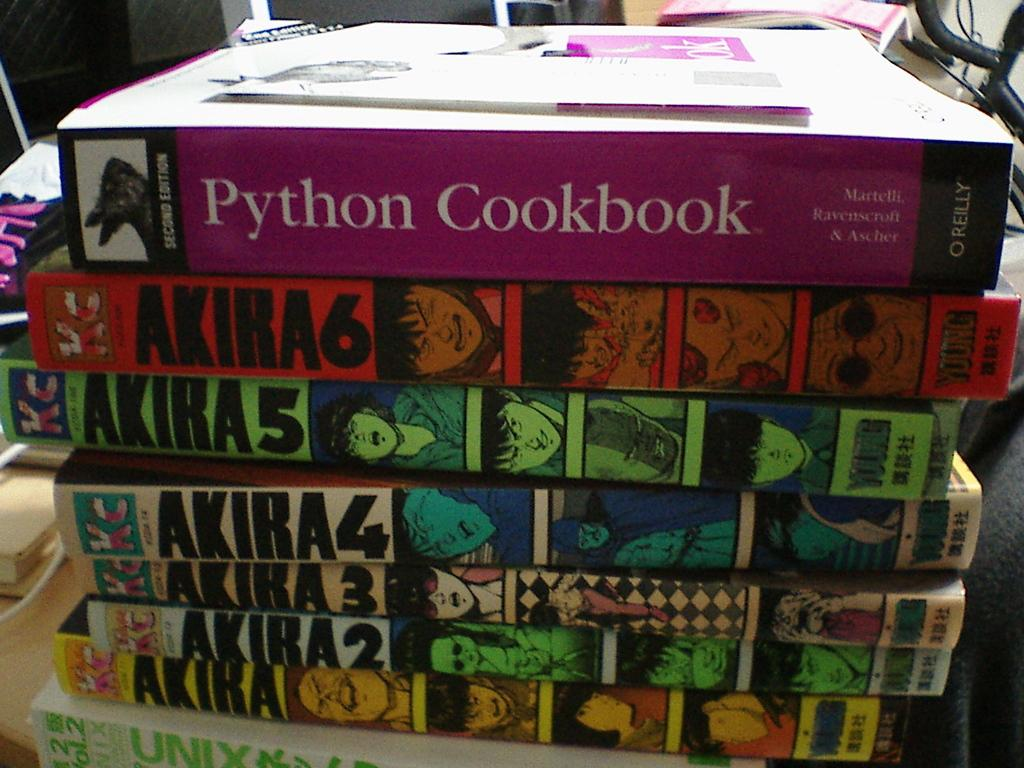<image>
Provide a brief description of the given image. A stack of books with the top on being Python Cookbook. 